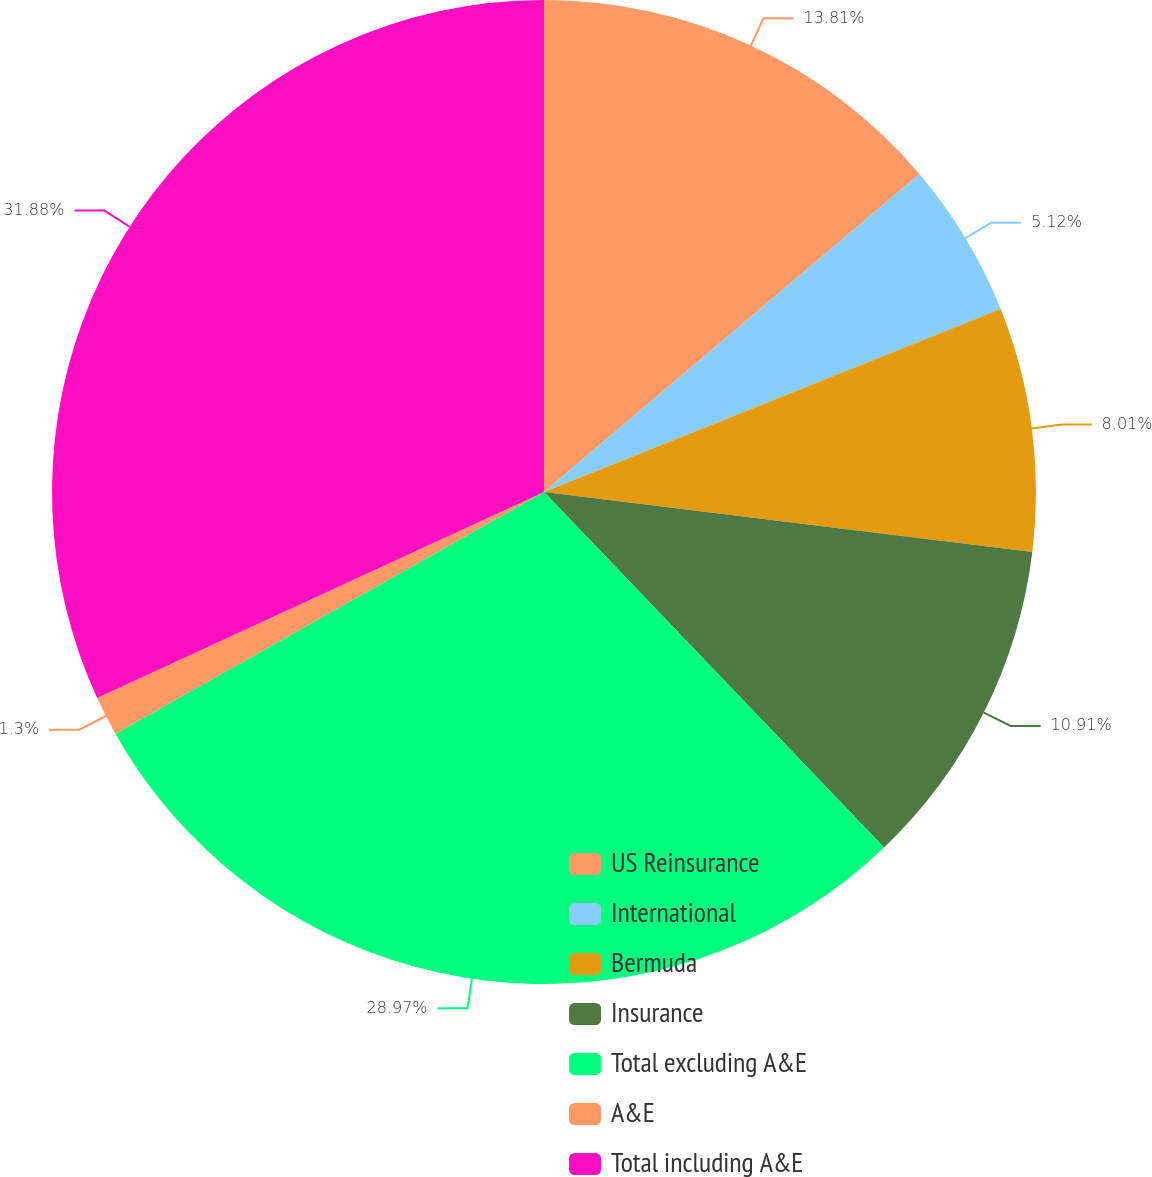<chart> <loc_0><loc_0><loc_500><loc_500><pie_chart><fcel>US Reinsurance<fcel>International<fcel>Bermuda<fcel>Insurance<fcel>Total excluding A&E<fcel>A&E<fcel>Total including A&E<nl><fcel>13.81%<fcel>5.12%<fcel>8.01%<fcel>10.91%<fcel>28.97%<fcel>1.3%<fcel>31.87%<nl></chart> 